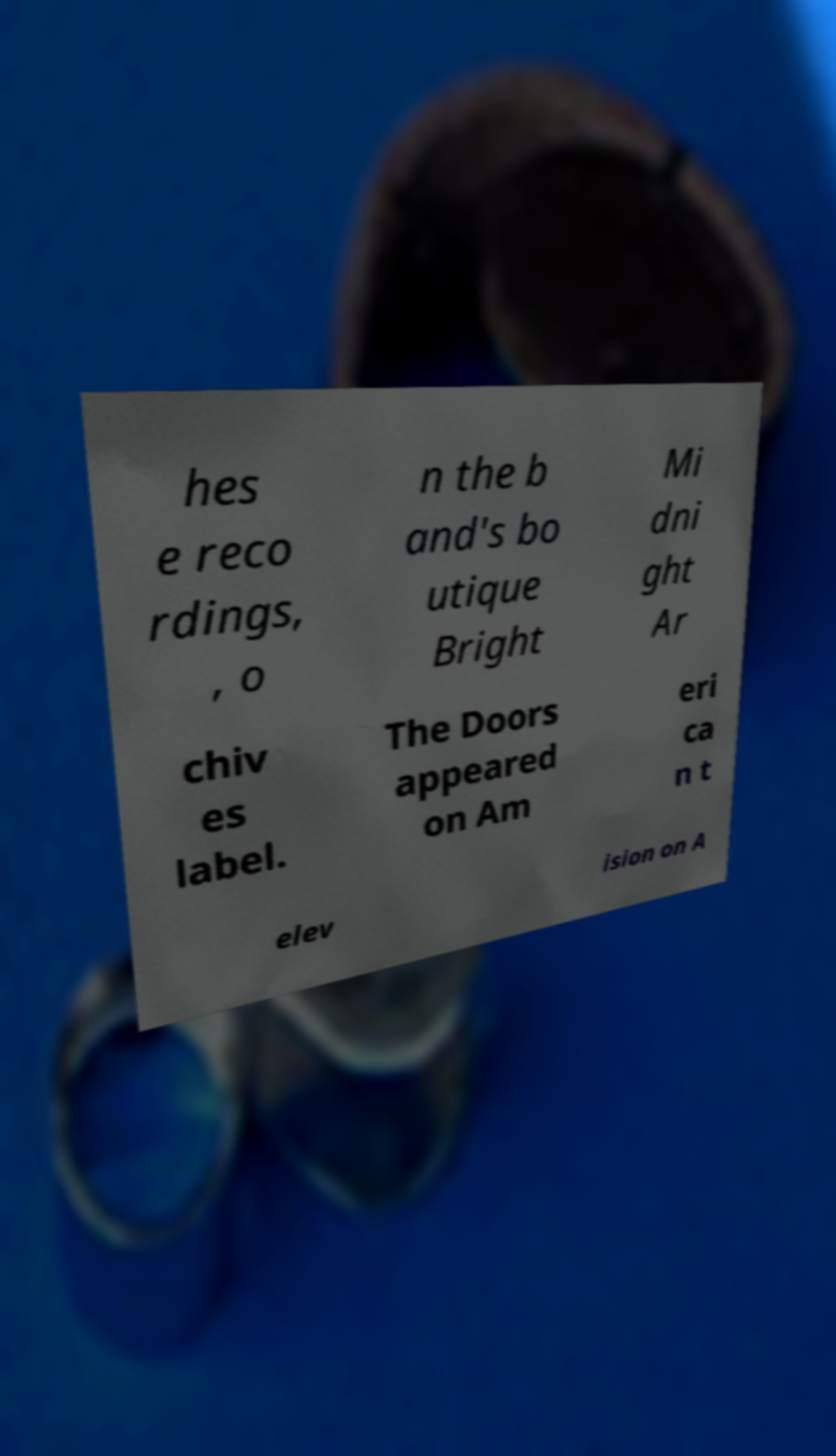Can you accurately transcribe the text from the provided image for me? hes e reco rdings, , o n the b and's bo utique Bright Mi dni ght Ar chiv es label. The Doors appeared on Am eri ca n t elev ision on A 